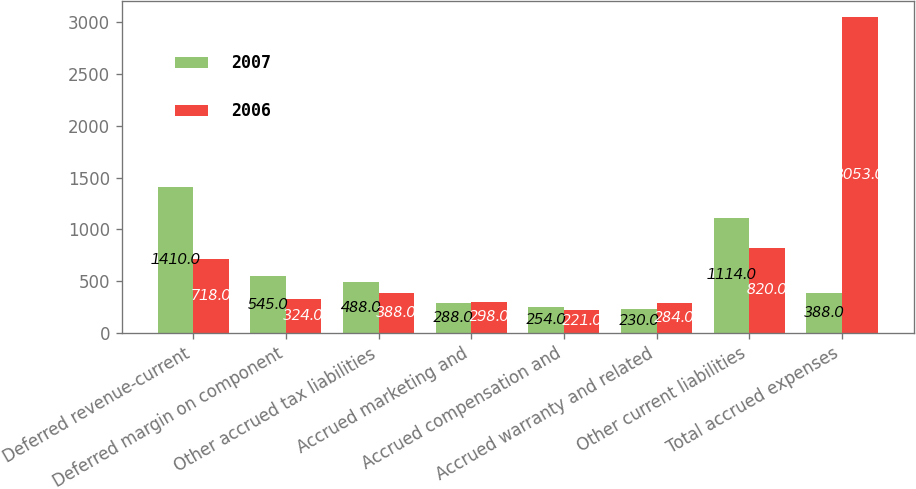Convert chart to OTSL. <chart><loc_0><loc_0><loc_500><loc_500><stacked_bar_chart><ecel><fcel>Deferred revenue-current<fcel>Deferred margin on component<fcel>Other accrued tax liabilities<fcel>Accrued marketing and<fcel>Accrued compensation and<fcel>Accrued warranty and related<fcel>Other current liabilities<fcel>Total accrued expenses<nl><fcel>2007<fcel>1410<fcel>545<fcel>488<fcel>288<fcel>254<fcel>230<fcel>1114<fcel>388<nl><fcel>2006<fcel>718<fcel>324<fcel>388<fcel>298<fcel>221<fcel>284<fcel>820<fcel>3053<nl></chart> 